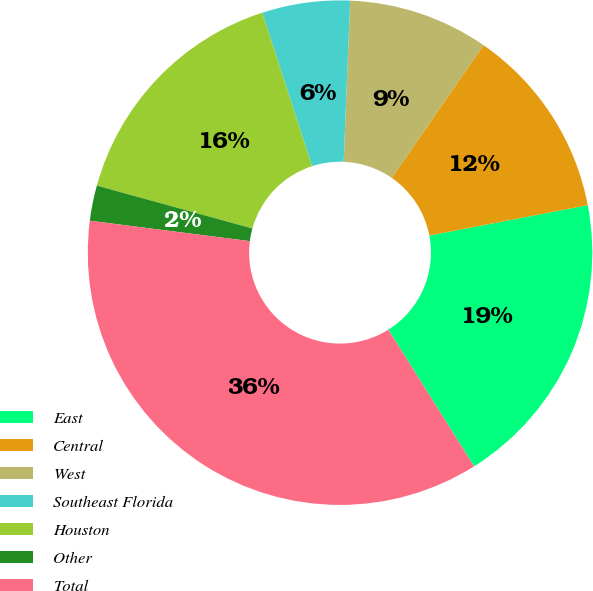Convert chart. <chart><loc_0><loc_0><loc_500><loc_500><pie_chart><fcel>East<fcel>Central<fcel>West<fcel>Southeast Florida<fcel>Houston<fcel>Other<fcel>Total<nl><fcel>19.1%<fcel>12.36%<fcel>8.99%<fcel>5.63%<fcel>15.73%<fcel>2.26%<fcel>35.94%<nl></chart> 